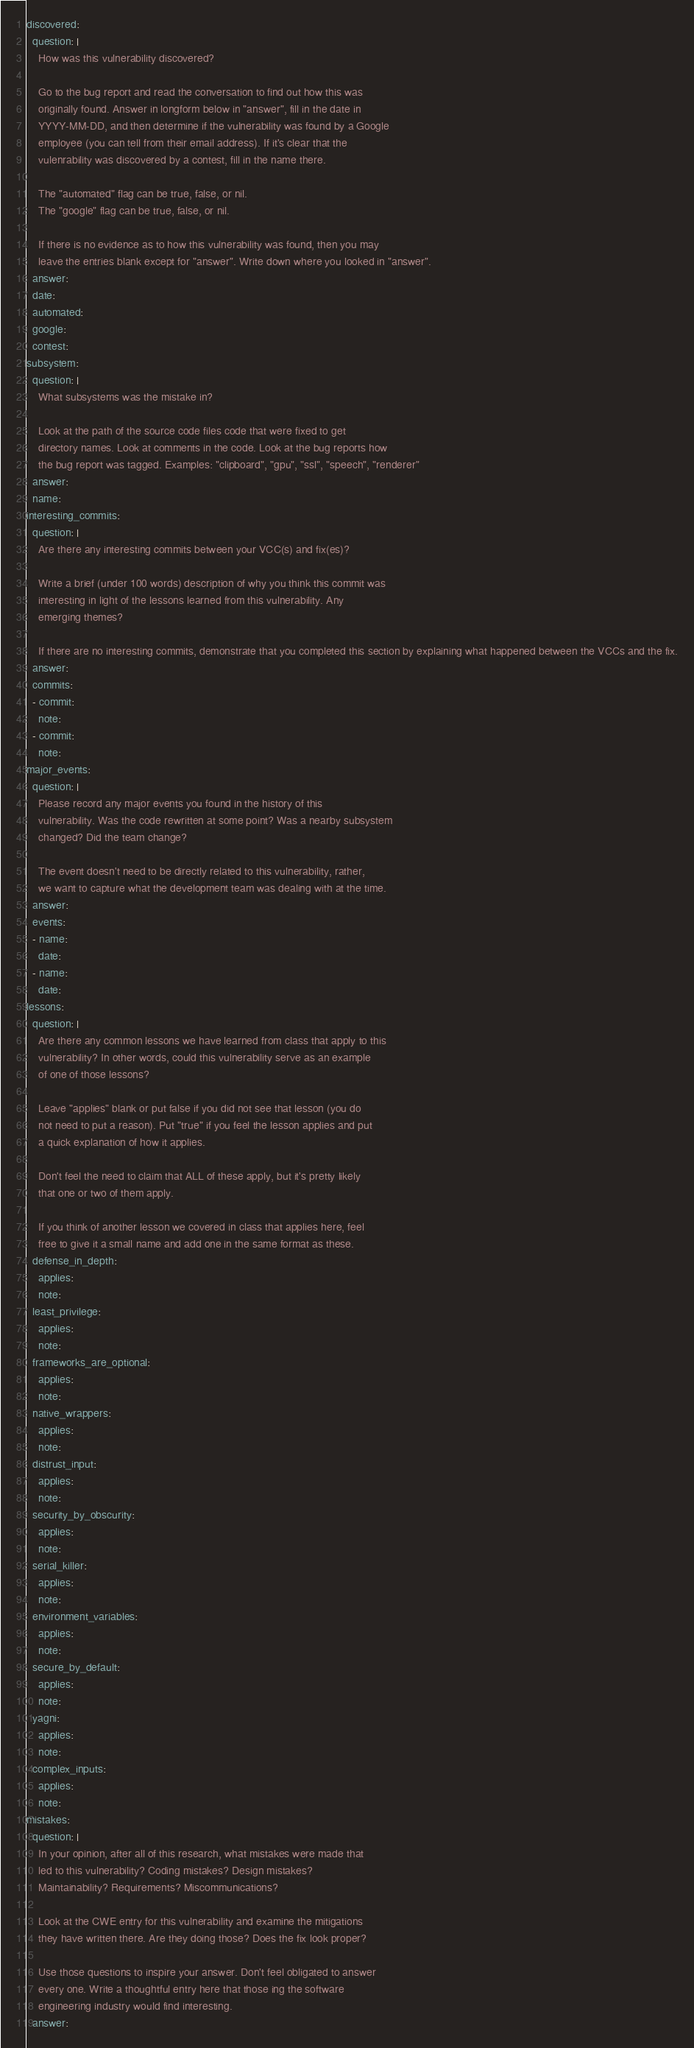<code> <loc_0><loc_0><loc_500><loc_500><_YAML_>discovered:
  question: |
    How was this vulnerability discovered?

    Go to the bug report and read the conversation to find out how this was
    originally found. Answer in longform below in "answer", fill in the date in
    YYYY-MM-DD, and then determine if the vulnerability was found by a Google
    employee (you can tell from their email address). If it's clear that the
    vulenrability was discovered by a contest, fill in the name there.

    The "automated" flag can be true, false, or nil.
    The "google" flag can be true, false, or nil.

    If there is no evidence as to how this vulnerability was found, then you may
    leave the entries blank except for "answer". Write down where you looked in "answer".
  answer: 
  date: 
  automated: 
  google: 
  contest: 
subsystem:
  question: |
    What subsystems was the mistake in?

    Look at the path of the source code files code that were fixed to get
    directory names. Look at comments in the code. Look at the bug reports how
    the bug report was tagged. Examples: "clipboard", "gpu", "ssl", "speech", "renderer"
  answer: 
  name: 
interesting_commits:
  question: |
    Are there any interesting commits between your VCC(s) and fix(es)?

    Write a brief (under 100 words) description of why you think this commit was
    interesting in light of the lessons learned from this vulnerability. Any
    emerging themes?

    If there are no interesting commits, demonstrate that you completed this section by explaining what happened between the VCCs and the fix.
  answer:
  commits:
  - commit: 
    note: 
  - commit: 
    note: 
major_events:
  question: |
    Please record any major events you found in the history of this
    vulnerability. Was the code rewritten at some point? Was a nearby subsystem
    changed? Did the team change?

    The event doesn't need to be directly related to this vulnerability, rather,
    we want to capture what the development team was dealing with at the time.
  answer: 
  events:
  - name: 
    date: 
  - name: 
    date: 
lessons:
  question: |
    Are there any common lessons we have learned from class that apply to this
    vulnerability? In other words, could this vulnerability serve as an example
    of one of those lessons?

    Leave "applies" blank or put false if you did not see that lesson (you do
    not need to put a reason). Put "true" if you feel the lesson applies and put
    a quick explanation of how it applies.

    Don't feel the need to claim that ALL of these apply, but it's pretty likely
    that one or two of them apply.

    If you think of another lesson we covered in class that applies here, feel
    free to give it a small name and add one in the same format as these.
  defense_in_depth:
    applies: 
    note: 
  least_privilege:
    applies: 
    note: 
  frameworks_are_optional:
    applies: 
    note: 
  native_wrappers:
    applies: 
    note: 
  distrust_input:
    applies: 
    note: 
  security_by_obscurity:
    applies: 
    note: 
  serial_killer:
    applies: 
    note: 
  environment_variables:
    applies: 
    note: 
  secure_by_default:
    applies: 
    note: 
  yagni:
    applies: 
    note: 
  complex_inputs:
    applies: 
    note: 
mistakes:
  question: |
    In your opinion, after all of this research, what mistakes were made that
    led to this vulnerability? Coding mistakes? Design mistakes?
    Maintainability? Requirements? Miscommunications?

    Look at the CWE entry for this vulnerability and examine the mitigations
    they have written there. Are they doing those? Does the fix look proper?

    Use those questions to inspire your answer. Don't feel obligated to answer
    every one. Write a thoughtful entry here that those ing the software
    engineering industry would find interesting.
  answer: 
</code> 